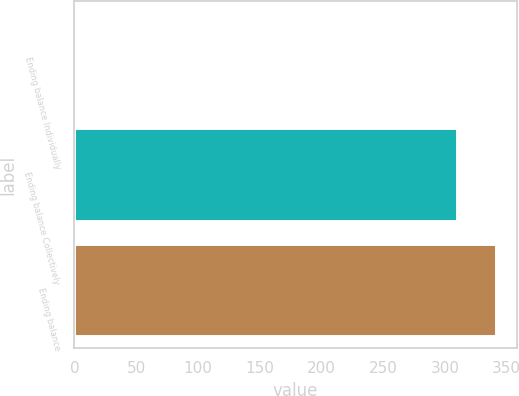Convert chart. <chart><loc_0><loc_0><loc_500><loc_500><bar_chart><fcel>Ending balance Individually<fcel>Ending balance Collectively<fcel>Ending balance<nl><fcel>1<fcel>310<fcel>341<nl></chart> 